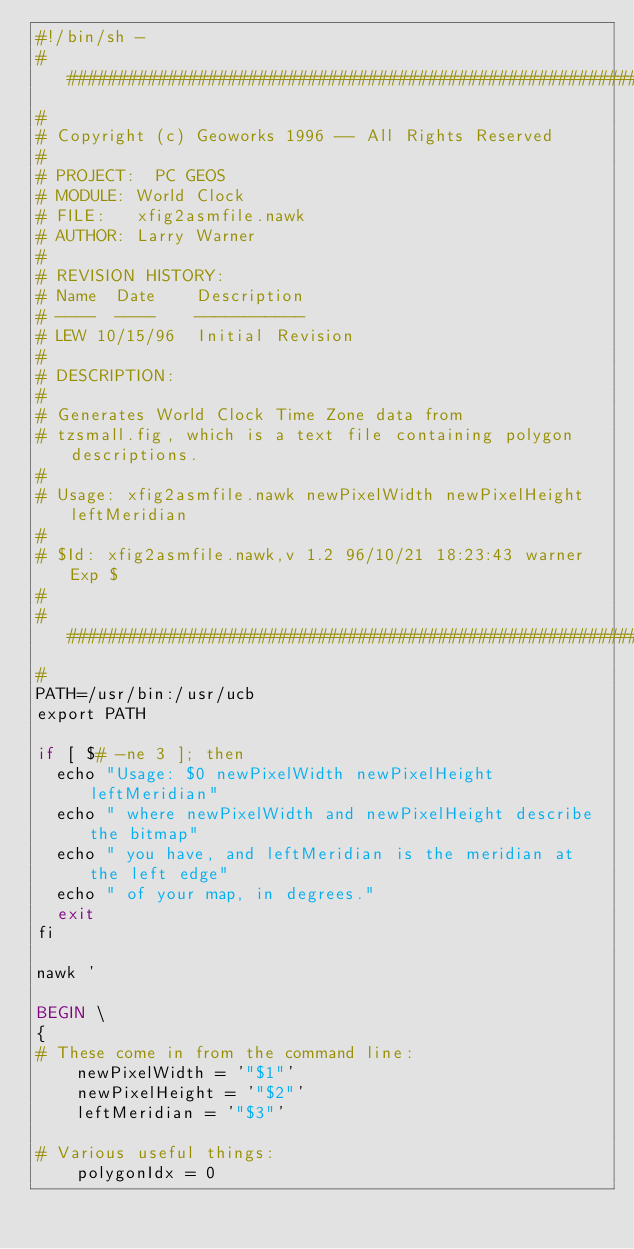Convert code to text. <code><loc_0><loc_0><loc_500><loc_500><_Awk_>#!/bin/sh -
##############################################################################
#
#	Copyright (c) Geoworks 1996 -- All Rights Reserved
#
# PROJECT:	PC GEOS
# MODULE:	World Clock
# FILE:		xfig2asmfile.nawk
# AUTHOR:	Larry Warner
#
# REVISION HISTORY:
#	Name	Date		Description
#	----	----		-----------
#	LEW	10/15/96	Initial Revision
#
# DESCRIPTION:
#
#	Generates World Clock Time Zone data from
#	tzsmall.fig, which is a text file containing polygon descriptions.
#
#	Usage: xfig2asmfile.nawk newPixelWidth newPixelHeight leftMeridian
#
#	$Id: xfig2asmfile.nawk,v 1.2 96/10/21 18:23:43 warner Exp $
#
###############################################################################
#
PATH=/usr/bin:/usr/ucb
export PATH

if [ $# -ne 3 ]; then
	echo "Usage: $0 newPixelWidth newPixelHeight leftMeridian"
	echo " where newPixelWidth and newPixelHeight describe the bitmap"
	echo " you have, and leftMeridian is the meridian at the left edge"
	echo " of your map, in degrees."
	exit
fi

nawk '

BEGIN \
{
# These come in from the command line:
    newPixelWidth = '"$1"'
    newPixelHeight = '"$2"'
    leftMeridian = '"$3"'

# Various useful things:
    polygonIdx = 0
</code> 